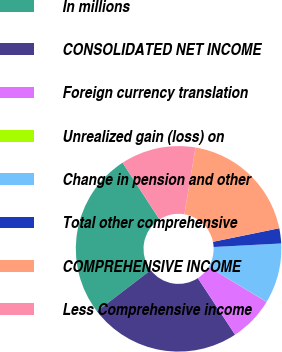Convert chart. <chart><loc_0><loc_0><loc_500><loc_500><pie_chart><fcel>In millions<fcel>CONSOLIDATED NET INCOME<fcel>Foreign currency translation<fcel>Unrealized gain (loss) on<fcel>Change in pension and other<fcel>Total other comprehensive<fcel>COMPREHENSIVE INCOME<fcel>Less Comprehensive income<nl><fcel>26.22%<fcel>23.87%<fcel>7.1%<fcel>0.02%<fcel>9.45%<fcel>2.38%<fcel>19.15%<fcel>11.81%<nl></chart> 